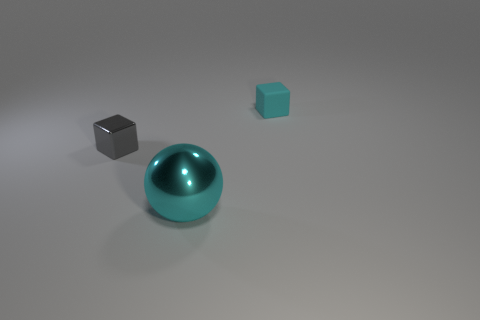Subtract all brown cubes. Subtract all yellow spheres. How many cubes are left? 2 Add 2 big metal spheres. How many objects exist? 5 Subtract all spheres. How many objects are left? 2 Add 1 large cyan shiny spheres. How many large cyan shiny spheres are left? 2 Add 3 gray metallic blocks. How many gray metallic blocks exist? 4 Subtract 1 gray cubes. How many objects are left? 2 Subtract all big purple spheres. Subtract all cyan things. How many objects are left? 1 